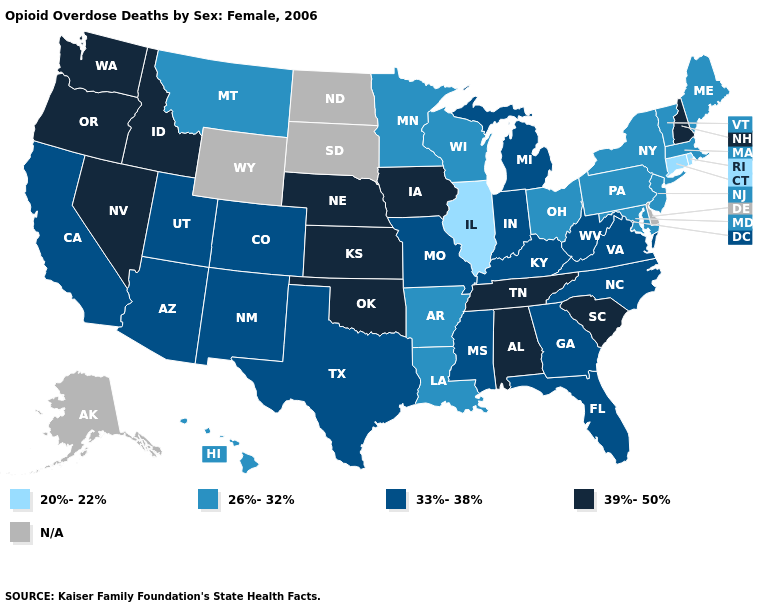How many symbols are there in the legend?
Keep it brief. 5. Among the states that border Mississippi , does Alabama have the highest value?
Concise answer only. Yes. What is the value of Delaware?
Short answer required. N/A. Does Washington have the highest value in the West?
Keep it brief. Yes. What is the value of Iowa?
Keep it brief. 39%-50%. Which states have the lowest value in the MidWest?
Concise answer only. Illinois. What is the value of South Carolina?
Short answer required. 39%-50%. Which states hav the highest value in the Northeast?
Answer briefly. New Hampshire. Among the states that border New York , does Connecticut have the lowest value?
Write a very short answer. Yes. What is the value of Kansas?
Be succinct. 39%-50%. Is the legend a continuous bar?
Quick response, please. No. Name the states that have a value in the range 33%-38%?
Short answer required. Arizona, California, Colorado, Florida, Georgia, Indiana, Kentucky, Michigan, Mississippi, Missouri, New Mexico, North Carolina, Texas, Utah, Virginia, West Virginia. 